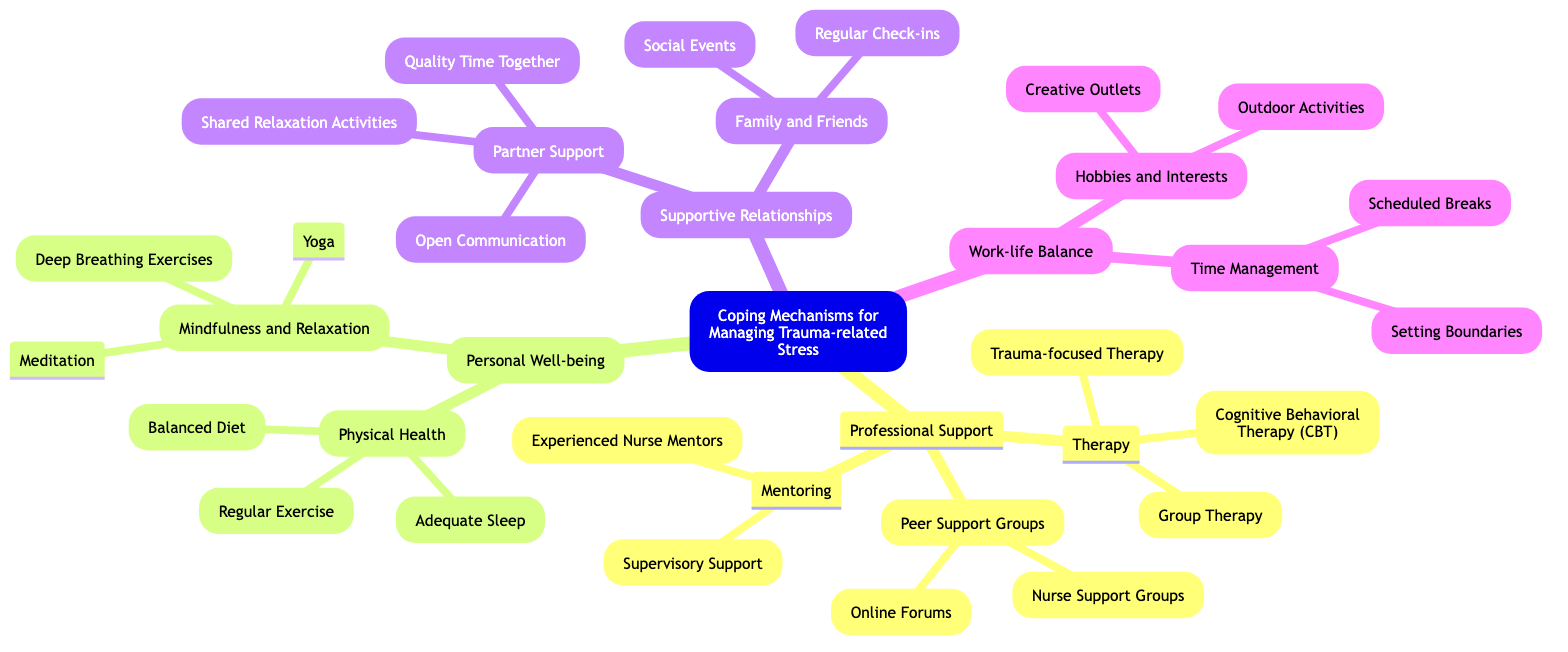What is the central idea of this mind map? The central idea is highlighted prominently at the top of the diagram. It states "Coping Mechanisms for Managing Trauma-related Stress."
Answer: Coping Mechanisms for Managing Trauma-related Stress How many main branches are there? By counting the major sections from the central idea, we identify four main branches: Professional Support, Personal Well-being, Supportive Relationships, and Work-life Balance.
Answer: 4 What therapy type falls under Professional Support? Scanning through the "Professional Support" branch, we find three therapy types listed: Cognitive Behavioral Therapy (CBT), Trauma-focused Therapy, and Group Therapy.
Answer: Cognitive Behavioral Therapy (CBT) Which branch includes “Quality Time Together”? The "Partner Support" sub-branch under "Supportive Relationships" lists “Quality Time Together” as one of its components.
Answer: Supportive Relationships What are the components listed under Mindfulness and Relaxation? Under the "Mindfulness and Relaxation" sub-branch, the diagram specifies three components: Meditation, Yoga, and Deep Breathing Exercises.
Answer: Meditation, Yoga, Deep Breathing Exercises Are there any sub-branches under Time Management? The "Time Management" sub-branch is part of the "Work-life Balance" main branch and it includes two sub-components: Setting Boundaries and Scheduled Breaks.
Answer: Yes Which two main branches focus on personal wellness? The two main branches that emphasize aspects of personal wellness are Personal Well-being and Supportive Relationships, as they both encompass strategies for emotional and mental health.
Answer: Personal Well-being, Supportive Relationships What type of support does mentoring provide? Mentoring provides two types of support listed under the "Mentoring" sub-branch: Experienced Nurse Mentors and Supervisory Support, specifically aimed at guiding and aiding individuals in a professional context.
Answer: Experienced Nurse Mentors, Supervisory Support Name one component under Physical Health. Under the "Physical Health" sub-branch, several components are listed, such as Regular Exercise, Balanced Diet, and Adequate Sleep. Any of these can be used as an answer.
Answer: Regular Exercise 